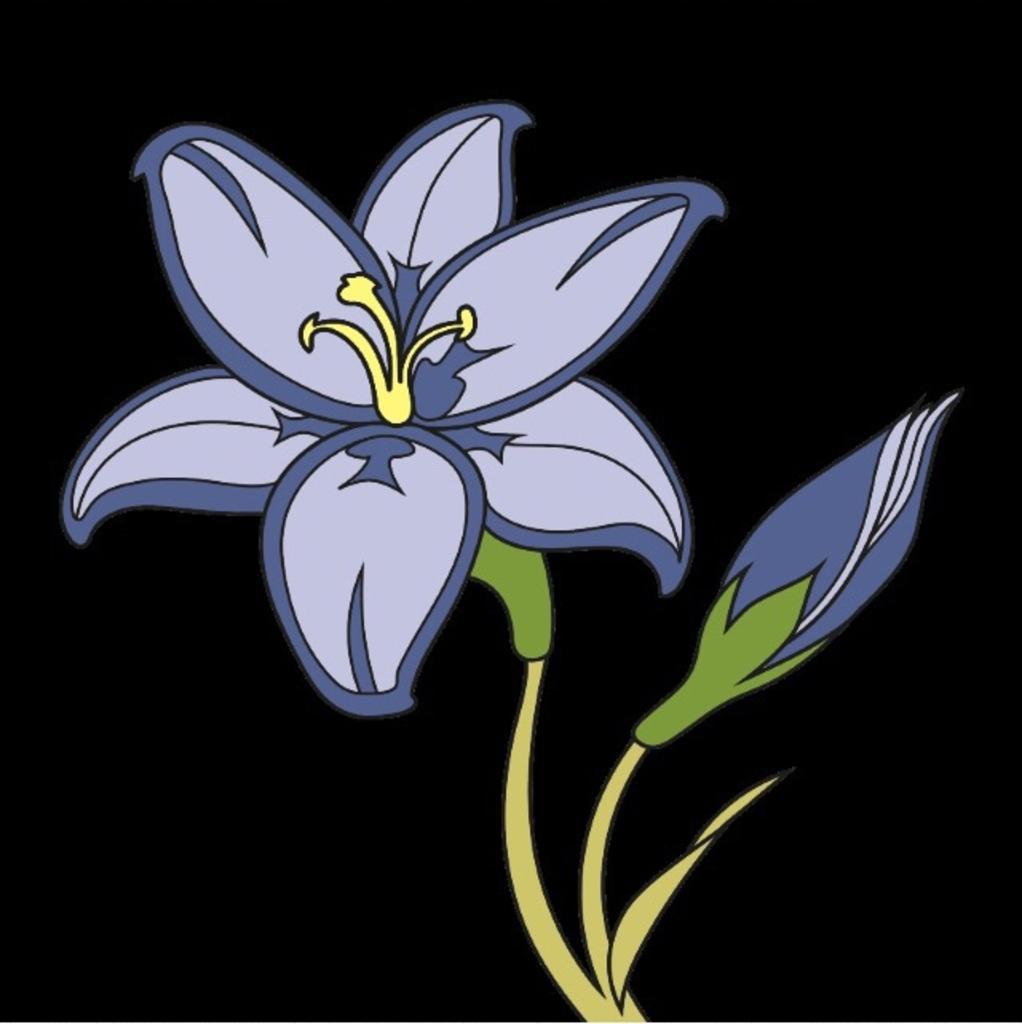Please provide a concise description of this image. This is a graphical image of a flower and a bud. And there is a dark background. 